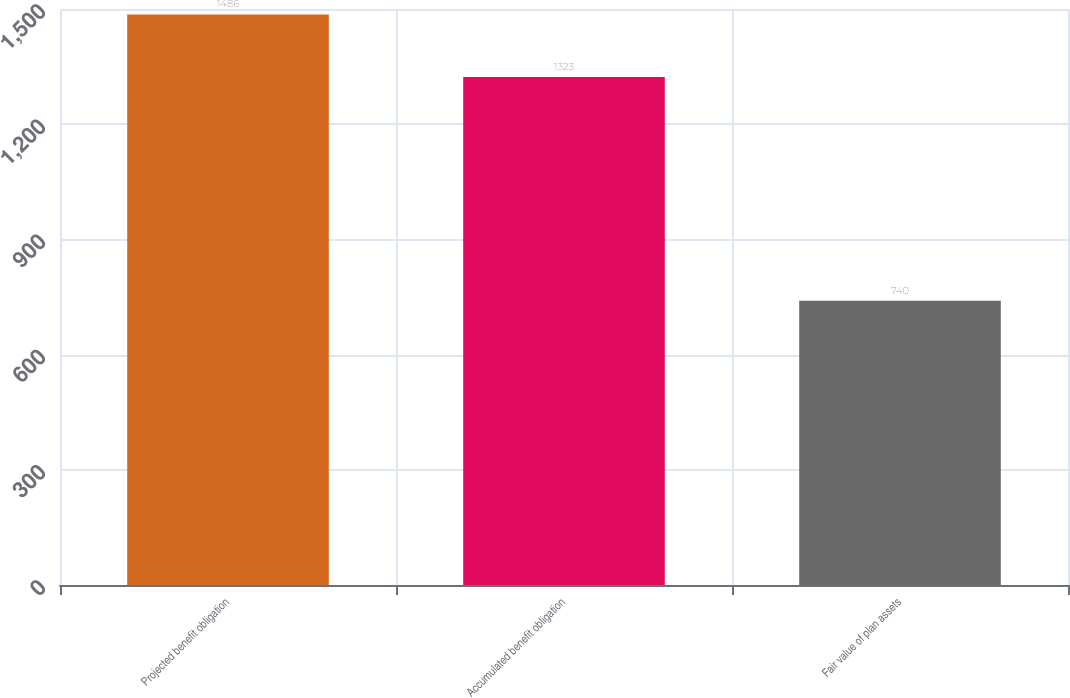Convert chart to OTSL. <chart><loc_0><loc_0><loc_500><loc_500><bar_chart><fcel>Projected benefit obligation<fcel>Accumulated benefit obligation<fcel>Fair value of plan assets<nl><fcel>1486<fcel>1323<fcel>740<nl></chart> 